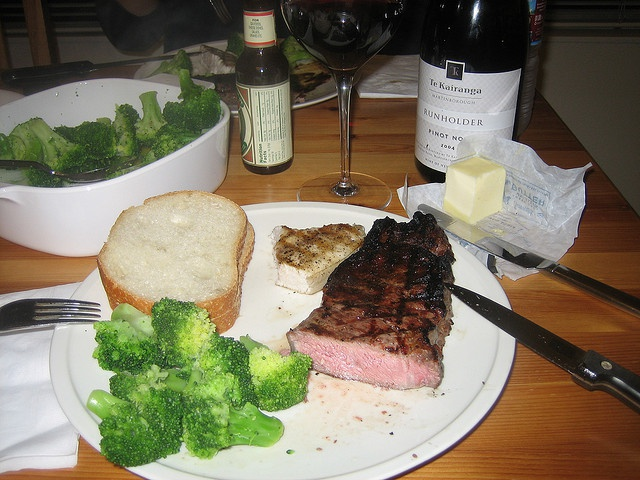Describe the objects in this image and their specific colors. I can see bowl in black, darkgray, lightgray, and darkgreen tones, broccoli in black, green, and darkgreen tones, dining table in black, brown, and maroon tones, bottle in black, darkgray, lightgray, and gray tones, and wine glass in black, brown, and maroon tones in this image. 